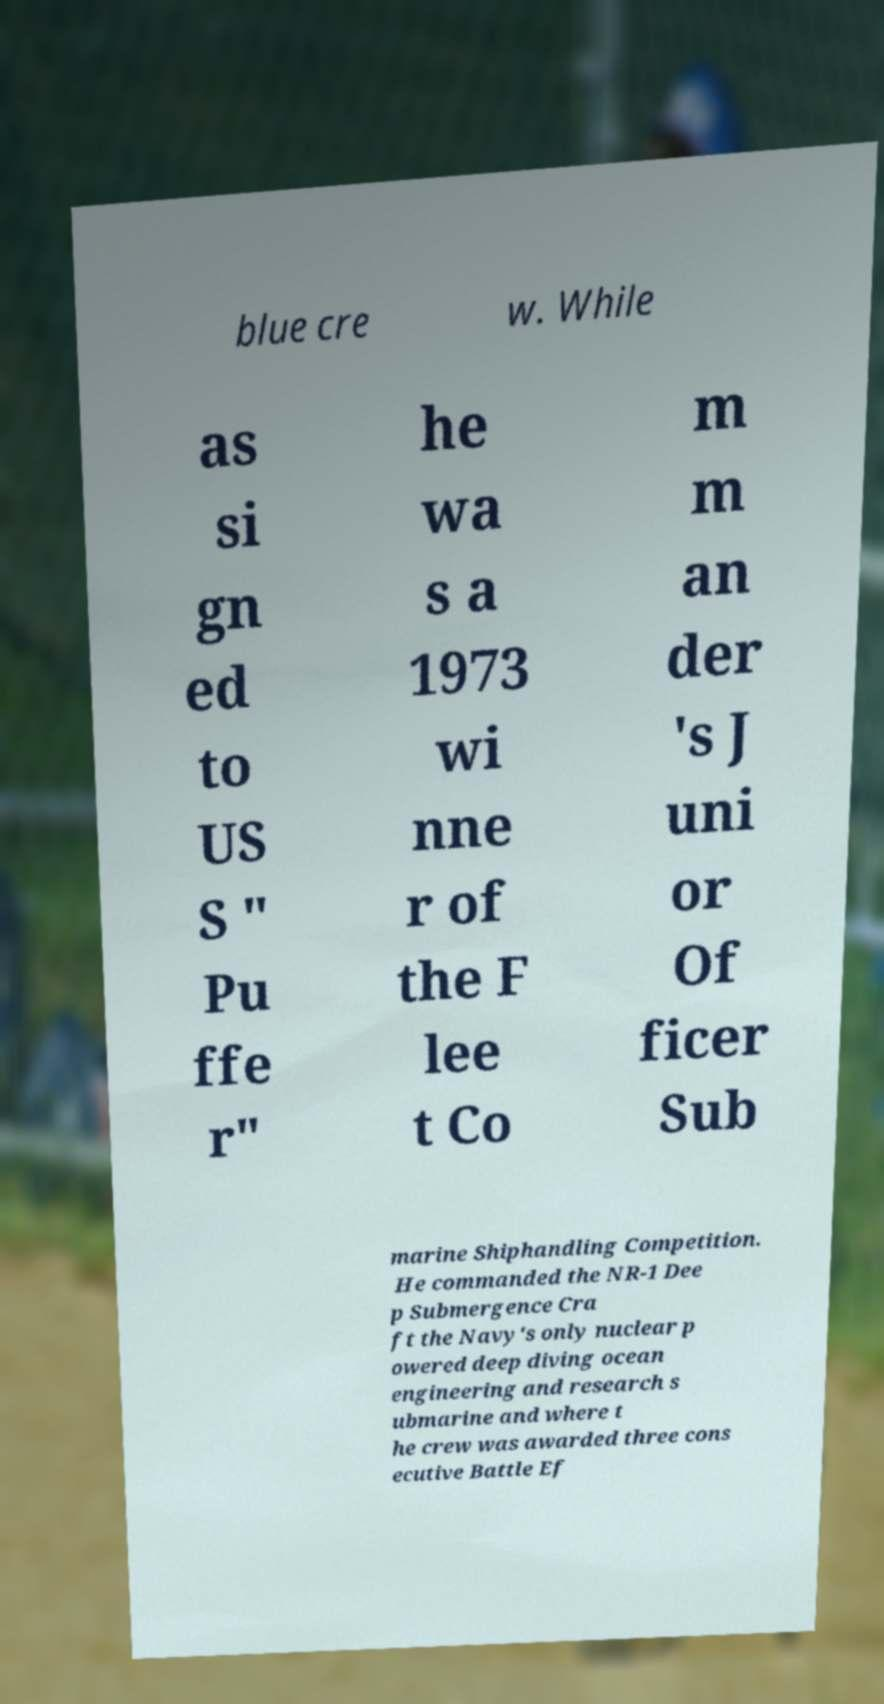For documentation purposes, I need the text within this image transcribed. Could you provide that? blue cre w. While as si gn ed to US S " Pu ffe r" he wa s a 1973 wi nne r of the F lee t Co m m an der 's J uni or Of ficer Sub marine Shiphandling Competition. He commanded the NR-1 Dee p Submergence Cra ft the Navy's only nuclear p owered deep diving ocean engineering and research s ubmarine and where t he crew was awarded three cons ecutive Battle Ef 